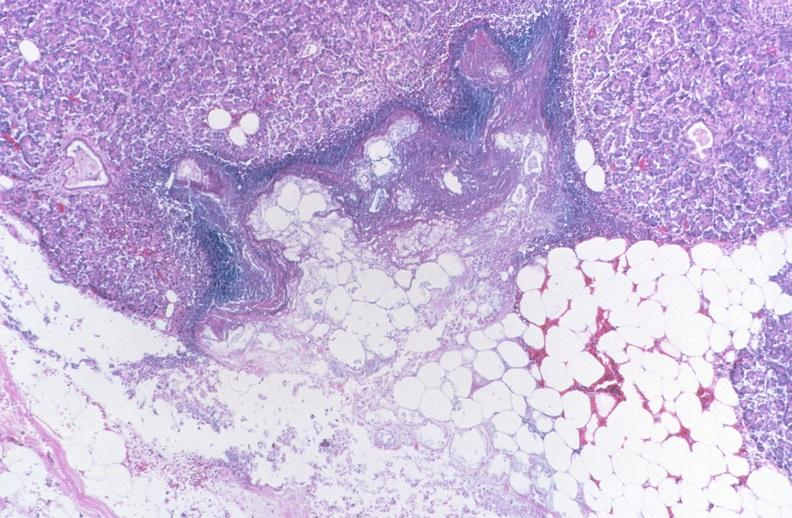does this image show pancreatic fat necrosis, pancreatitis/necrosis?
Answer the question using a single word or phrase. Yes 